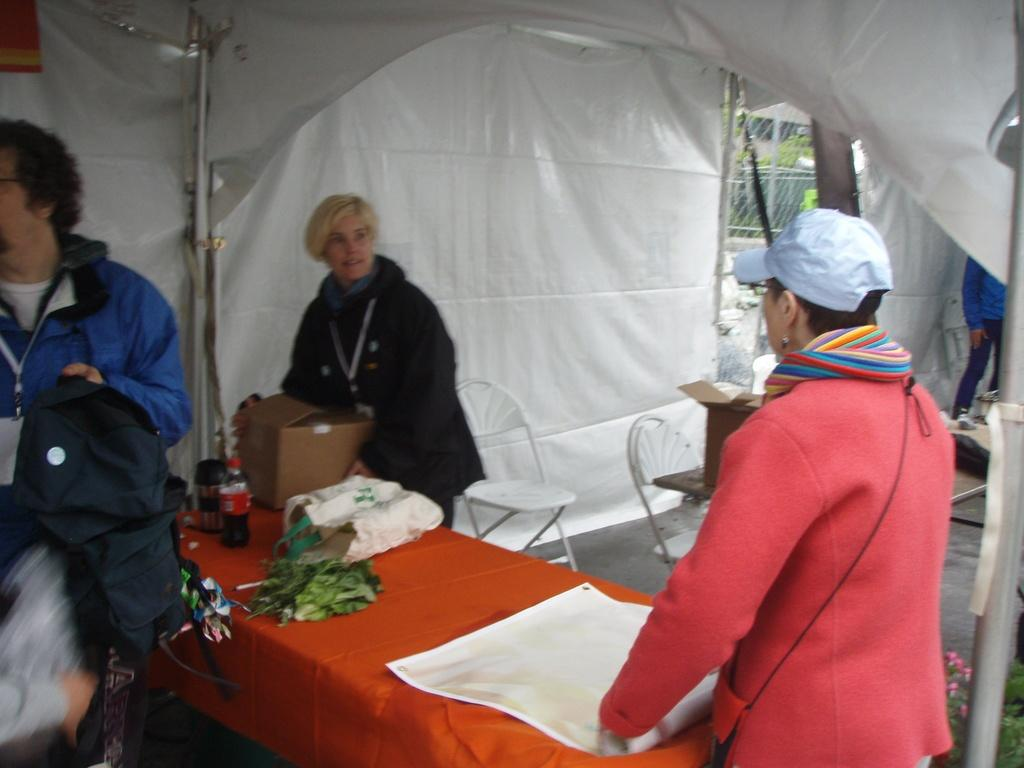Who is present in the image? There is a woman and another person in the image. What is the woman holding in the image? The woman is holding a box in the image. Where is the box located? The box is kept on a table in the image. What is the other person holding in the image? The other person is holding a jacket in the image. What type of pet can be seen in the image? There is no pet visible in the image. What kind of plantation is shown in the background of the image? There is no plantation present in the image. 